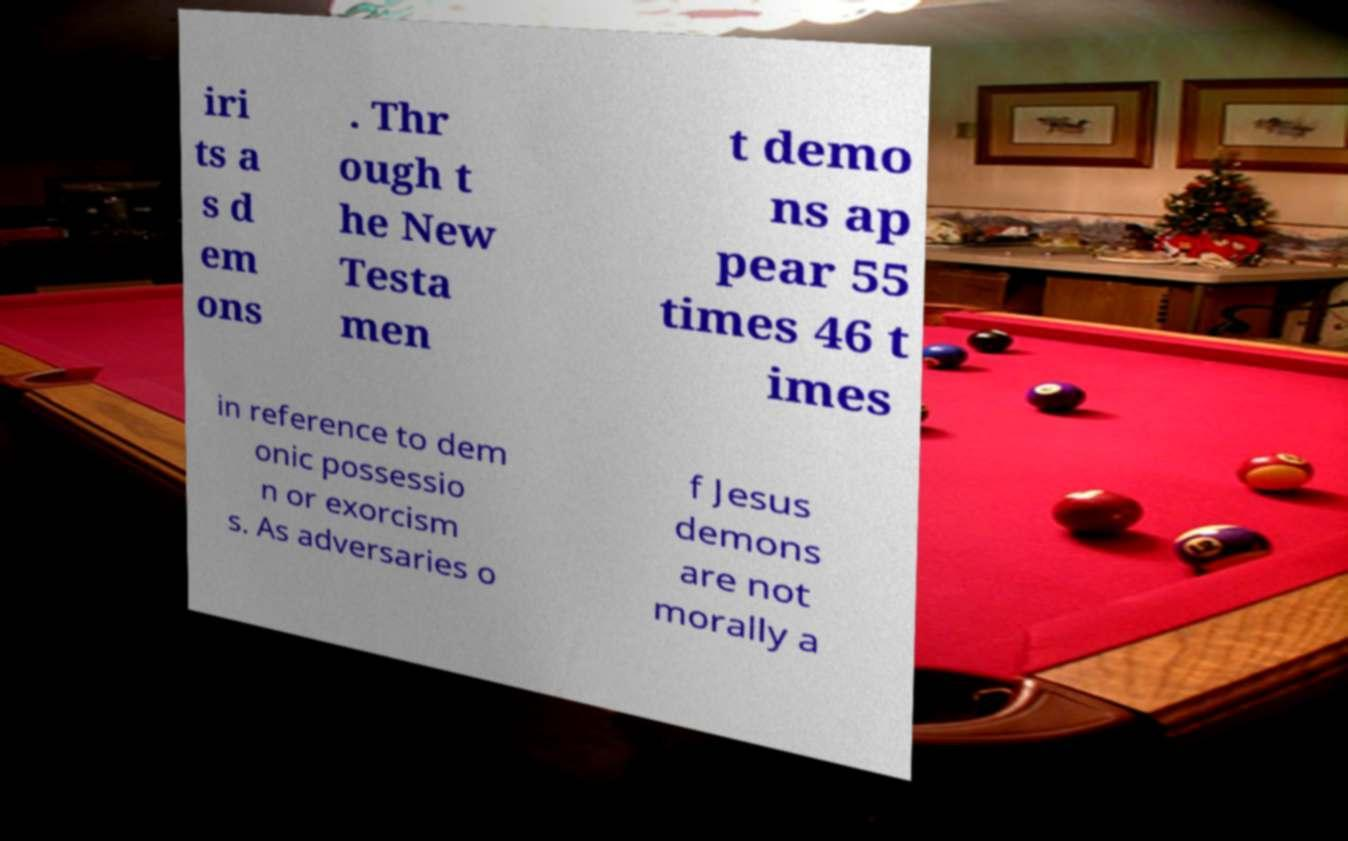There's text embedded in this image that I need extracted. Can you transcribe it verbatim? iri ts a s d em ons . Thr ough t he New Testa men t demo ns ap pear 55 times 46 t imes in reference to dem onic possessio n or exorcism s. As adversaries o f Jesus demons are not morally a 